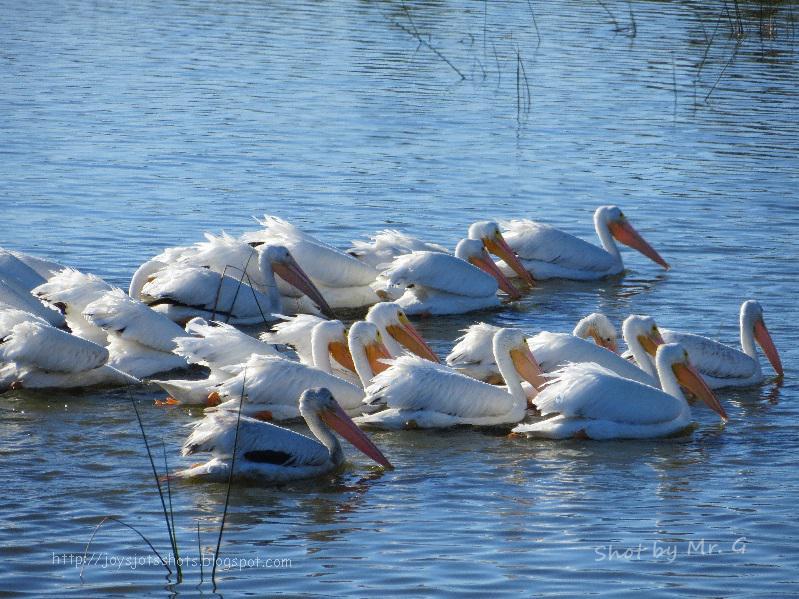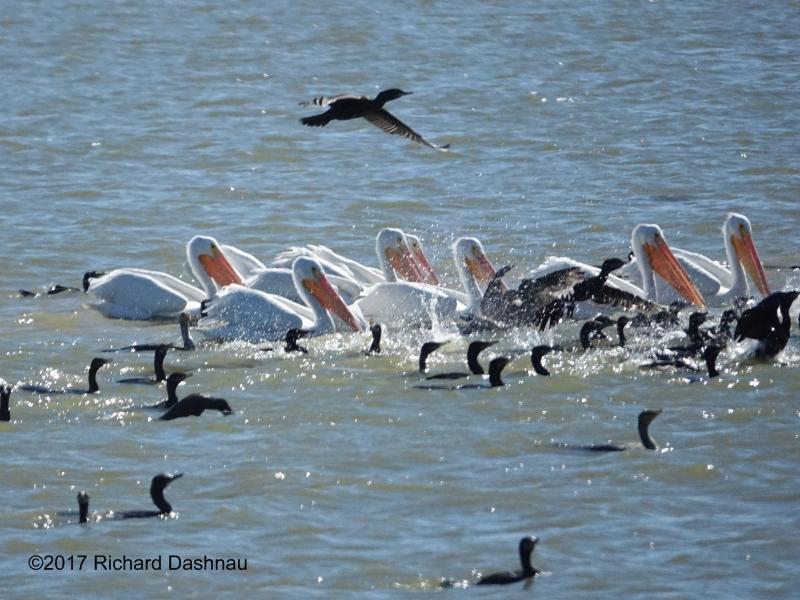The first image is the image on the left, the second image is the image on the right. Analyze the images presented: Is the assertion "All of the pelicans are swimming." valid? Answer yes or no. Yes. The first image is the image on the left, the second image is the image on the right. Assess this claim about the two images: "The birds in both images are swimming.". Correct or not? Answer yes or no. Yes. 